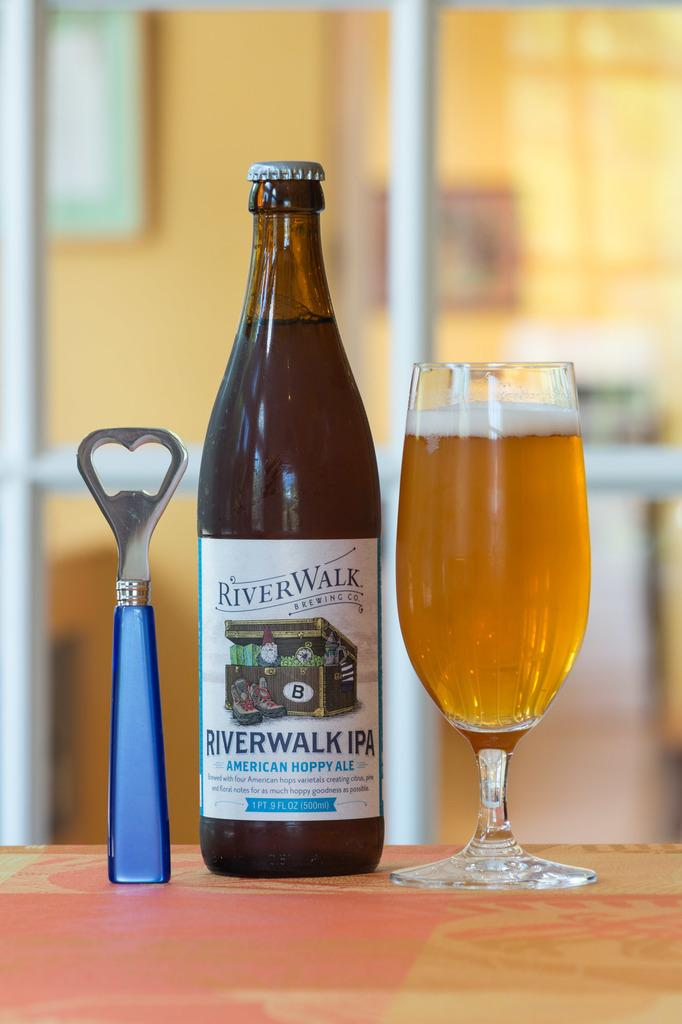<image>
Write a terse but informative summary of the picture. Bottle of beer named Riverwalk next to a bottle opener and a glass of beer. 